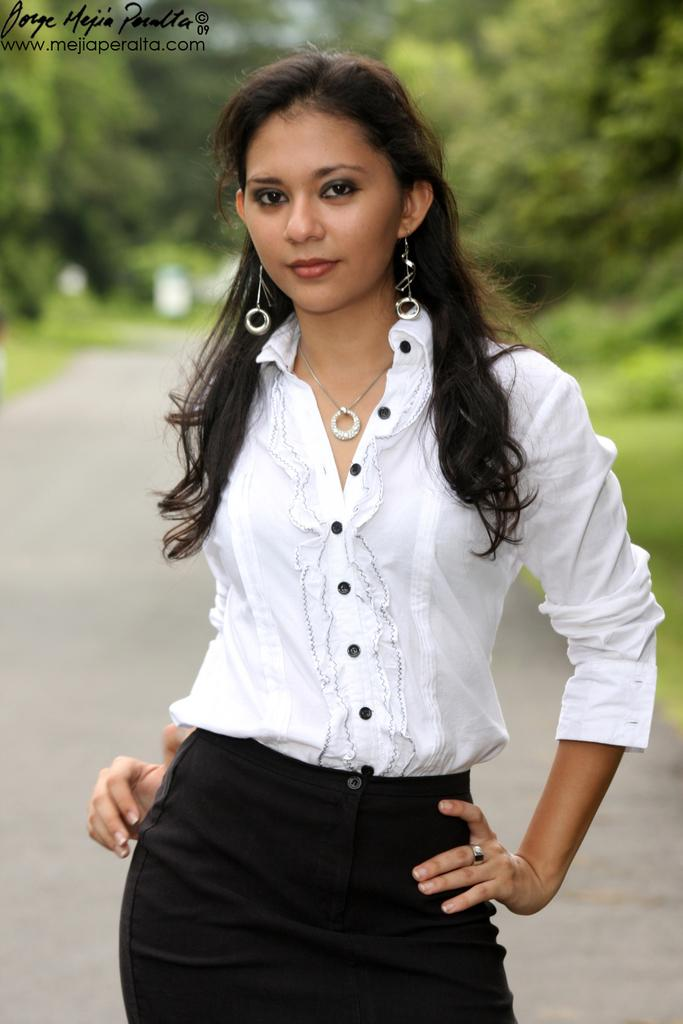What is the main subject of the image? There is a girl standing in the image. What can be seen in the background of the image? There are green trees in the background of the image. What type of sheet is the girl using to practice law in the image? There is no sheet or reference to practicing law in the image; it simply features a girl standing in front of green trees. 